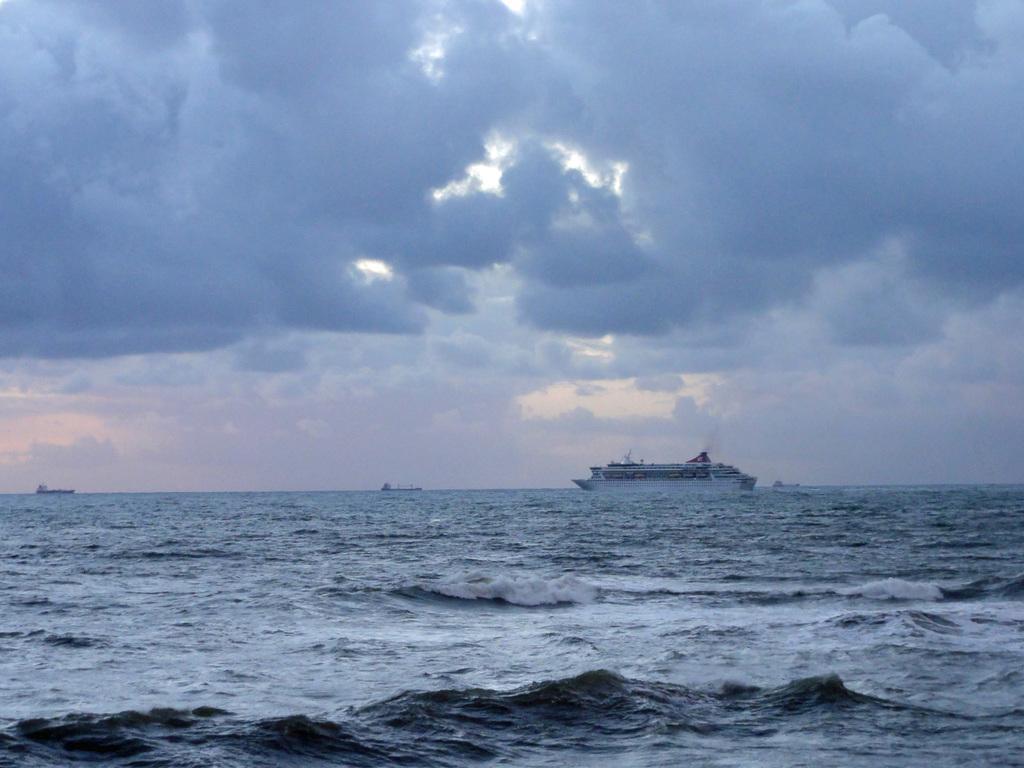Describe this image in one or two sentences. In this image, we can see a ship floating on the water. There are clouds in the sky. 